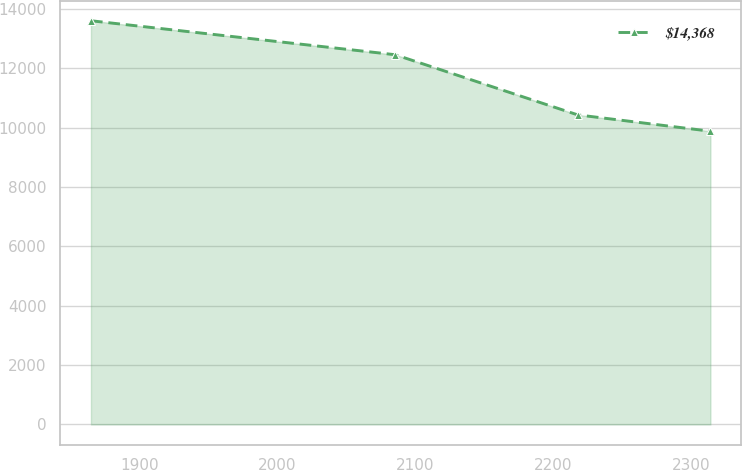<chart> <loc_0><loc_0><loc_500><loc_500><line_chart><ecel><fcel>$14,368<nl><fcel>1864.86<fcel>13596.9<nl><fcel>2085.42<fcel>12452.9<nl><fcel>2217.82<fcel>10426.5<nl><fcel>2314.06<fcel>9875.86<nl></chart> 